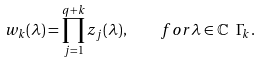<formula> <loc_0><loc_0><loc_500><loc_500>w _ { k } ( \lambda ) = \prod _ { j = 1 } ^ { q + k } z _ { j } ( \lambda ) , \quad f o r \lambda \in \mathbb { C } \ \Gamma _ { k } .</formula> 